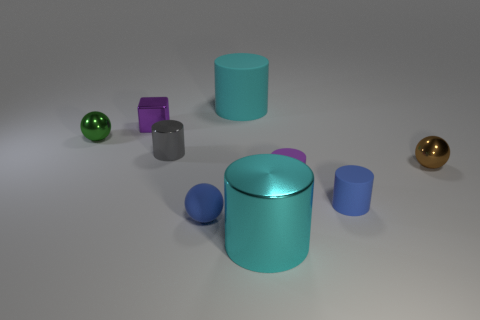Subtract all small blue rubber cylinders. How many cylinders are left? 4 Subtract all red blocks. How many cyan cylinders are left? 2 Subtract all blue cylinders. How many cylinders are left? 4 Subtract 3 cylinders. How many cylinders are left? 2 Subtract all balls. How many objects are left? 6 Subtract all cyan spheres. Subtract all gray cubes. How many spheres are left? 3 Subtract 1 brown balls. How many objects are left? 8 Subtract all tiny brown objects. Subtract all tiny gray metal cylinders. How many objects are left? 7 Add 9 brown things. How many brown things are left? 10 Add 3 gray cylinders. How many gray cylinders exist? 4 